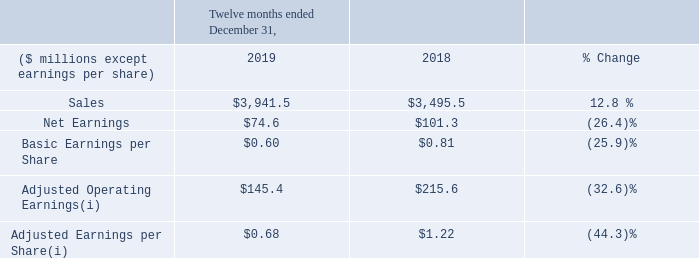1. THE BUSINESS
Maple Leaf Foods Inc. (“Maple Leaf Foods” or the "Company") is a producer of food products under leading brands including Maple
Leaf®, Maple Leaf Prime®, Schneiders®, Mina®, Greenfield Natural Meat Co.®, Swift®, Lightlife®, and Field Roast Grain Meat Co.™
The Company's portfolio includes prepared meats, ready-to-cook and ready-to-serve meals, valued-added fresh pork and poultry and
plant protein products. The address of the Company's registered office is 6985 Financial Dr. Mississauga, Ontario, L5N 0A1, Canada.
The Company employs approximately 13,000 people and does business primarily in Canada, the U.S. and Asia. The Company's shares trade on the Toronto Stock Exchange (MFI).
1. THE BUSINESS Maple Leaf Foods Inc. (“Maple Leaf Foods” or the "Company") is a producer of food products under leading brands including Maple Leaf®, Maple Leaf Prime®, Schneiders®, Mina®, Greenfield Natural Meat Co.®, Swift®, Lightlife®, and Field Roast Grain Meat Co.™ The Company's portfolio includes prepared meats, ready-to-cook and ready-to-serve meals, valued-added fresh pork and poultry and plant protein products. The address of the Company's registered office is 6985 Financial Dr. Mississauga, Ontario, L5N 0A1, Canada. The Company employs approximately 13,000 people and does business primarily in Canada, the U.S. and Asia. The Company's shares trade on the Toronto Stock Exchange (MFI).
Sales for 2019 were $3,941.5 million compared to $3,495.5 million last year, an increase of 12.8%. Excluding acquisitions, sales increased 5.2%, driven by favourable pricing, mix and volume in meat protein and accelerated growth in plant protein of 23.6%.
Net earnings for 2019 were $74.6 million ($0.60 per basic share) compared to $101.3 million ($0.81 per basic share) last year. Strong commercial performance and favourable resolution of income tax audits were more than offset by strategic investments in plant protein to drive top line growth and heightened volatility in hog prices. Net earnings were negatively impacted by $12.1 million due to non-cash fair value changes in biological assets and derivative contracts, which are excluded in the calculation of Adjusted Operating Earnings below.
Adjusted Operating Earnings for 2019 were $145.4 million compared to $215.6 million last year, and Adjusted Earnings per Share for
2019 were $0.68 compared to $1.22 last year due to similar factors as noted above.
For further discussion on key metrics and a discussion of results by operating segment, refer to the section titled Operating Review
starting on page 3 of this document.
What is the net earnings per worker in 2019?
Answer scale should be: million. 74.6/13,000
Answer: 0.01. Why did sales increase in 2019? Driven by favourable pricing, mix and volume in meat protein and accelerated growth in plant protein. How much are the expenses in 2019?
Answer scale should be: million. 3,941.5-74.6
Answer: 3866.9. Why did net earnings fall in 2019? Strategic investments in plant protein to drive top line growth and heightened volatility in hog prices. How are acquisitions calculated in change of sales? Excluding acquisitions, sales increased. How many outstanding shares does the company has in 2019?
Answer scale should be: million. 74.6/0.6
Answer: 124.33. 